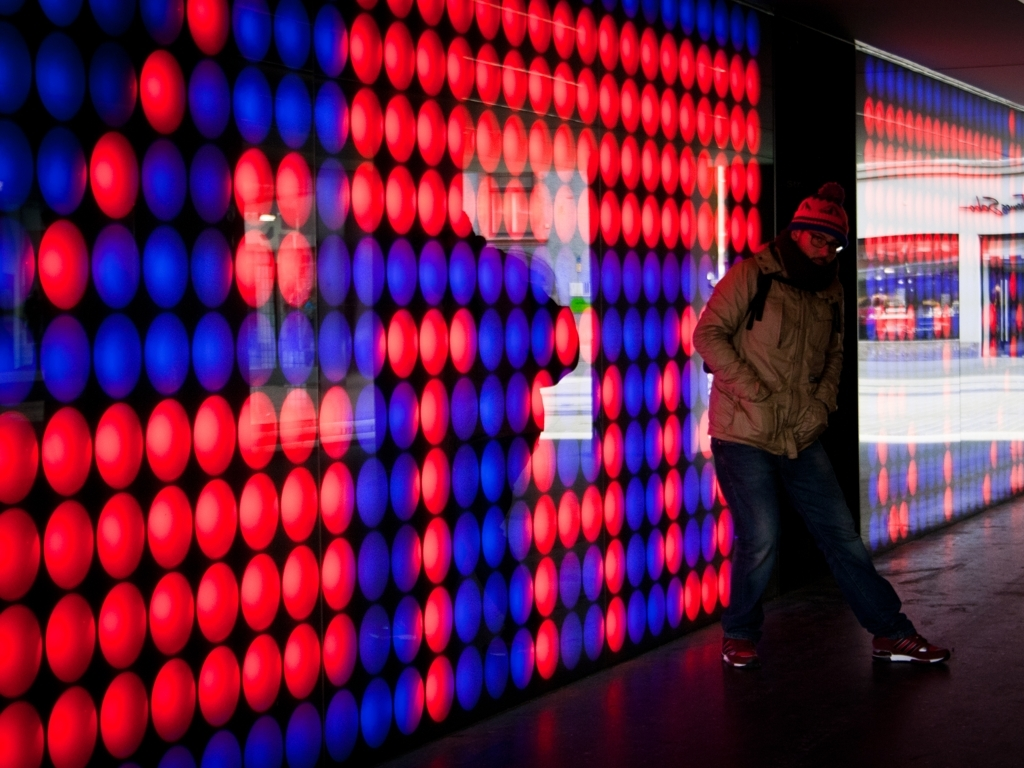Are there any blurriness issues in the image? The image appears to be clear without any noticeable issues of blurriness. The subject is in focus, and the background lights are intentionally exhibiting motion blur, which adds to the dynamic quality of the photo rather than detracting from it. 